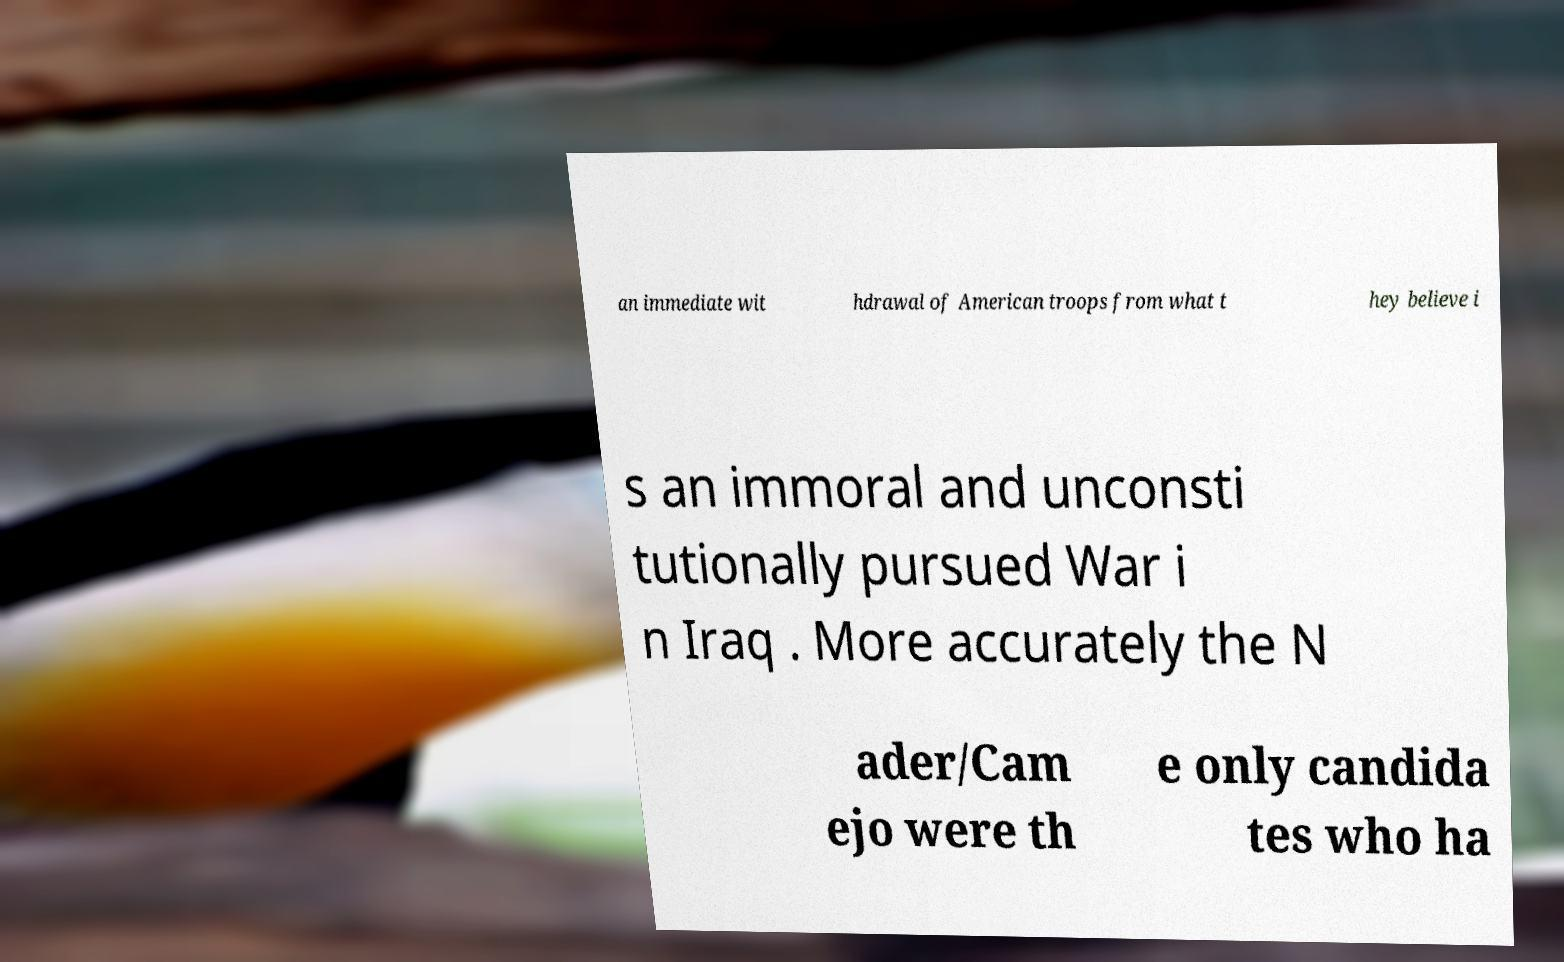Please read and relay the text visible in this image. What does it say? an immediate wit hdrawal of American troops from what t hey believe i s an immoral and unconsti tutionally pursued War i n Iraq . More accurately the N ader/Cam ejo were th e only candida tes who ha 